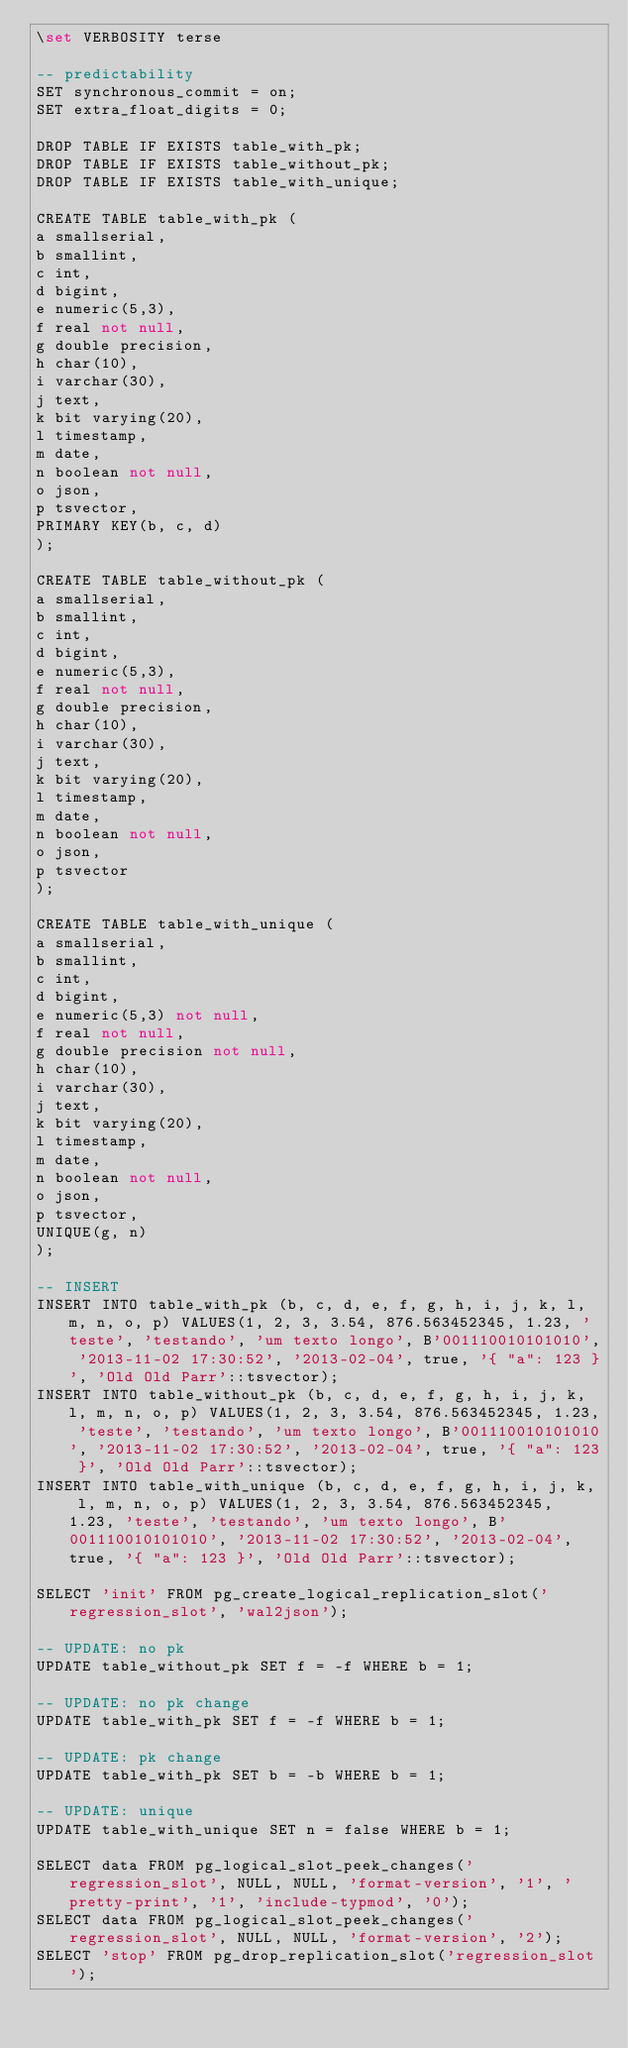Convert code to text. <code><loc_0><loc_0><loc_500><loc_500><_SQL_>\set VERBOSITY terse

-- predictability
SET synchronous_commit = on;
SET extra_float_digits = 0;

DROP TABLE IF EXISTS table_with_pk;
DROP TABLE IF EXISTS table_without_pk;
DROP TABLE IF EXISTS table_with_unique;

CREATE TABLE table_with_pk (
a	smallserial,
b	smallint,
c	int,
d	bigint,
e	numeric(5,3),
f	real not null,
g	double precision,
h	char(10),
i	varchar(30),
j	text,
k	bit varying(20),
l	timestamp,
m	date,
n	boolean not null,
o	json,
p	tsvector,
PRIMARY KEY(b, c, d)
);

CREATE TABLE table_without_pk (
a	smallserial,
b	smallint,
c	int,
d	bigint,
e	numeric(5,3),
f	real not null,
g	double precision,
h	char(10),
i	varchar(30),
j	text,
k	bit varying(20),
l	timestamp,
m	date,
n	boolean not null,
o	json,
p	tsvector
);

CREATE TABLE table_with_unique (
a	smallserial,
b	smallint,
c	int,
d	bigint,
e	numeric(5,3) not null,
f	real not null,
g	double precision not null,
h	char(10),
i	varchar(30),
j	text,
k	bit varying(20),
l	timestamp,
m	date,
n	boolean not null,
o	json,
p	tsvector,
UNIQUE(g, n)
);

-- INSERT
INSERT INTO table_with_pk (b, c, d, e, f, g, h, i, j, k, l, m, n, o, p) VALUES(1, 2, 3, 3.54, 876.563452345, 1.23, 'teste', 'testando', 'um texto longo', B'001110010101010', '2013-11-02 17:30:52', '2013-02-04', true, '{ "a": 123 }', 'Old Old Parr'::tsvector);
INSERT INTO table_without_pk (b, c, d, e, f, g, h, i, j, k, l, m, n, o, p) VALUES(1, 2, 3, 3.54, 876.563452345, 1.23, 'teste', 'testando', 'um texto longo', B'001110010101010', '2013-11-02 17:30:52', '2013-02-04', true, '{ "a": 123 }', 'Old Old Parr'::tsvector);
INSERT INTO table_with_unique (b, c, d, e, f, g, h, i, j, k, l, m, n, o, p) VALUES(1, 2, 3, 3.54, 876.563452345, 1.23, 'teste', 'testando', 'um texto longo', B'001110010101010', '2013-11-02 17:30:52', '2013-02-04', true, '{ "a": 123 }', 'Old Old Parr'::tsvector);

SELECT 'init' FROM pg_create_logical_replication_slot('regression_slot', 'wal2json');

-- UPDATE: no pk
UPDATE table_without_pk SET f = -f WHERE b = 1;

-- UPDATE: no pk change
UPDATE table_with_pk SET f = -f WHERE b = 1;

-- UPDATE: pk change
UPDATE table_with_pk SET b = -b WHERE b = 1;

-- UPDATE: unique
UPDATE table_with_unique SET n = false WHERE b = 1;

SELECT data FROM pg_logical_slot_peek_changes('regression_slot', NULL, NULL, 'format-version', '1', 'pretty-print', '1', 'include-typmod', '0');
SELECT data FROM pg_logical_slot_peek_changes('regression_slot', NULL, NULL, 'format-version', '2');
SELECT 'stop' FROM pg_drop_replication_slot('regression_slot');
</code> 